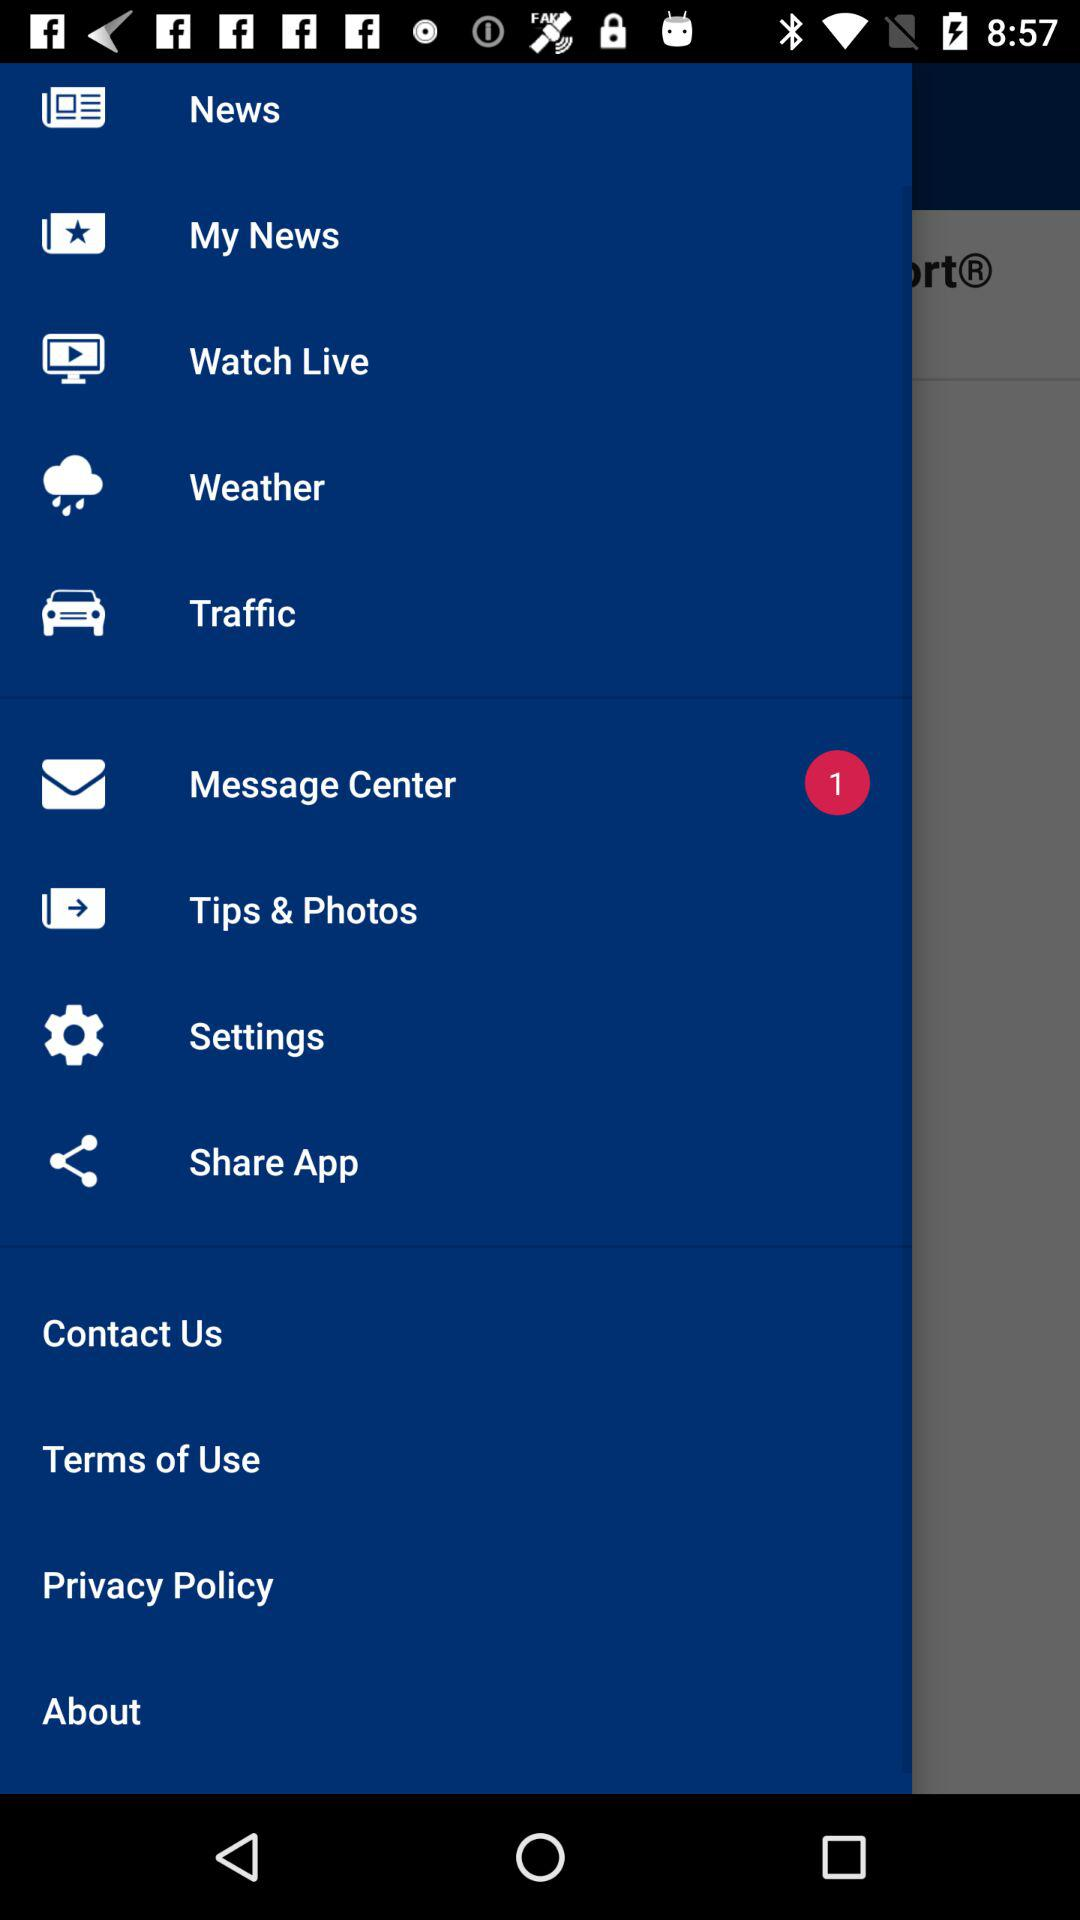How many unread messages are there? There is 1 unread message. 